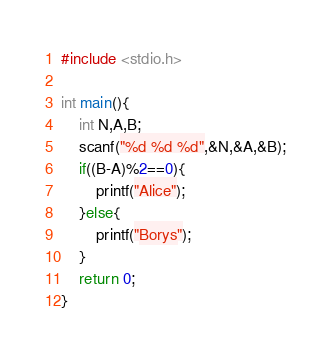Convert code to text. <code><loc_0><loc_0><loc_500><loc_500><_C_>#include <stdio.h>

int main(){
    int N,A,B;
    scanf("%d %d %d",&N,&A,&B);
    if((B-A)%2==0){
        printf("Alice");
    }else{
        printf("Borys");
    }
    return 0;
}</code> 